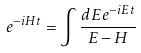<formula> <loc_0><loc_0><loc_500><loc_500>e ^ { - i H t } = \int \frac { d E e ^ { - i E t } } { E - H }</formula> 